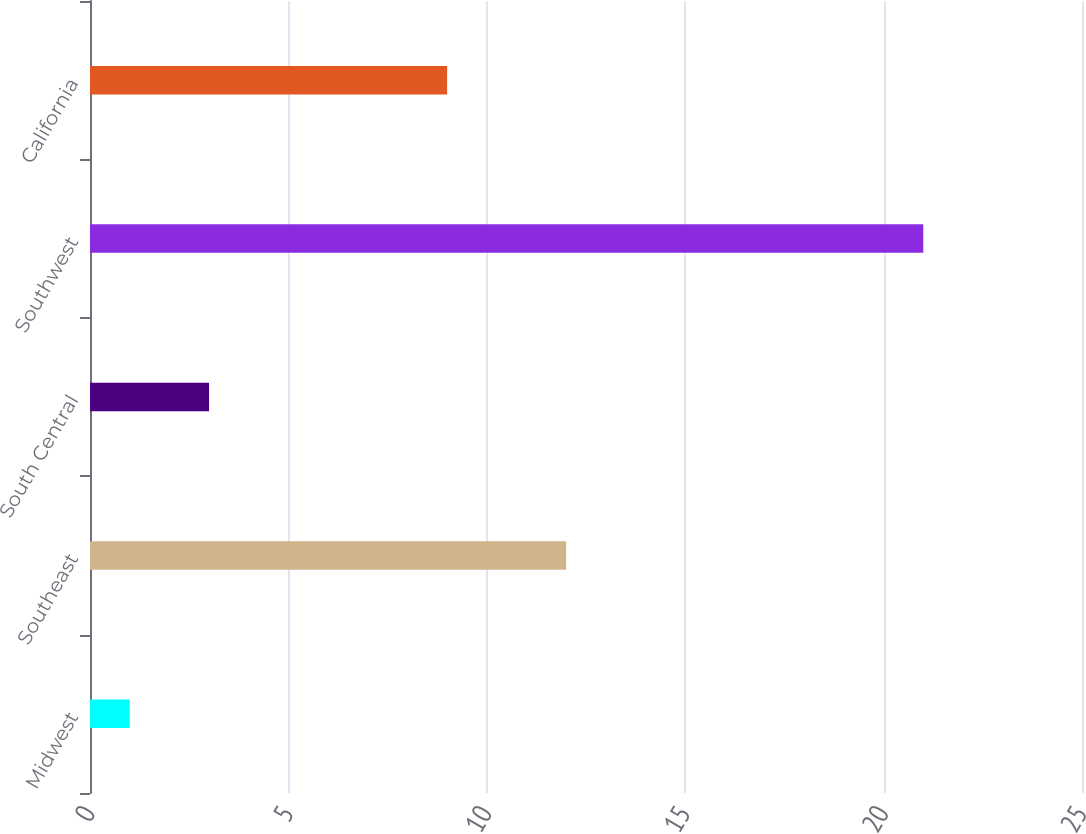Convert chart to OTSL. <chart><loc_0><loc_0><loc_500><loc_500><bar_chart><fcel>Midwest<fcel>Southeast<fcel>South Central<fcel>Southwest<fcel>California<nl><fcel>1<fcel>12<fcel>3<fcel>21<fcel>9<nl></chart> 